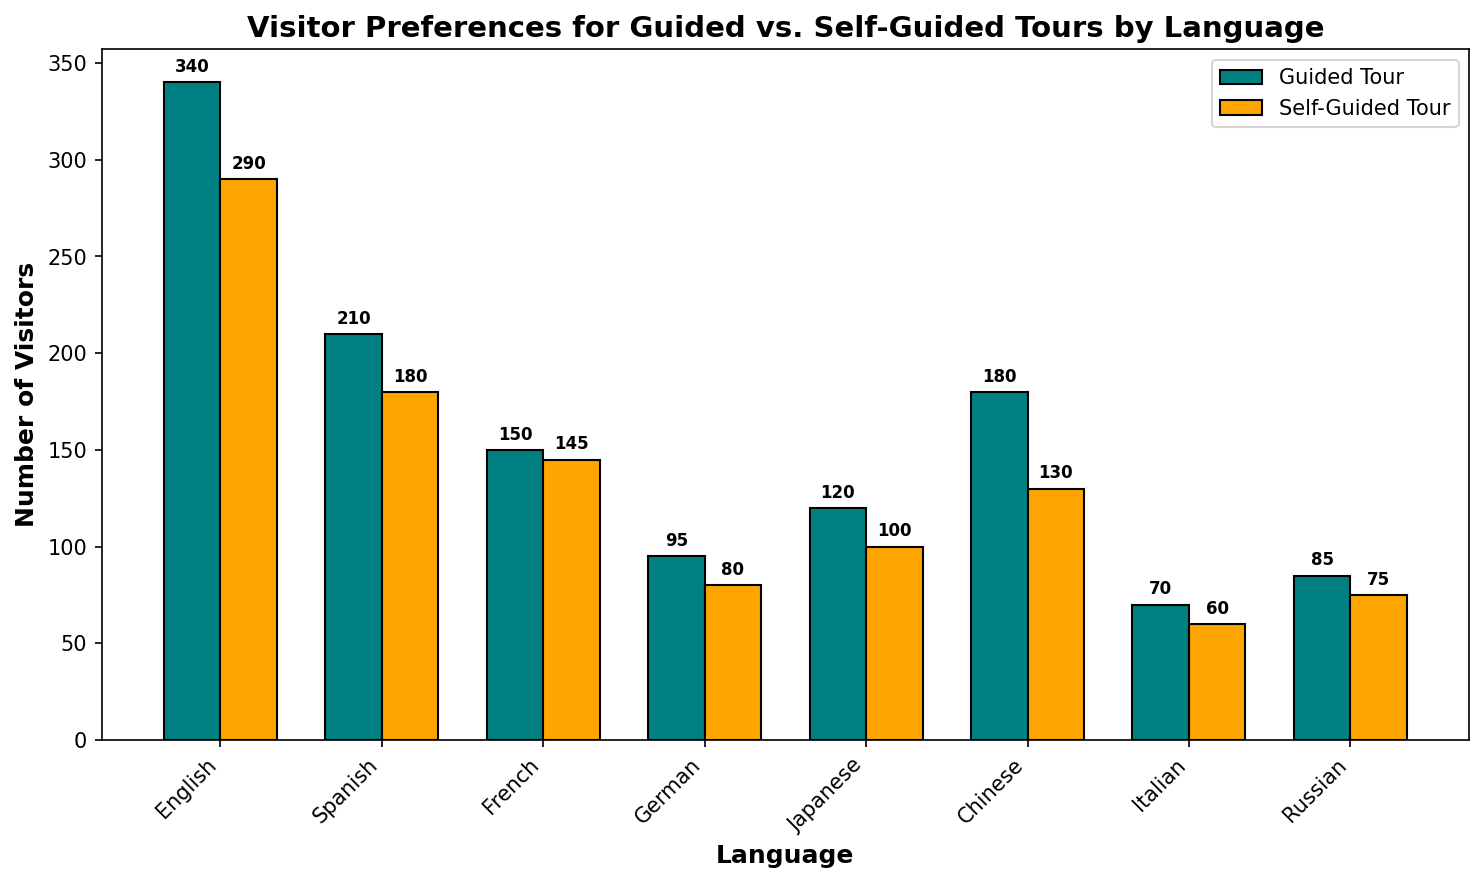Which language has the highest number of visitors for guided tours? To determine the language with the highest number of guided tour visitors, examine the tallest bar among the guided tour bars (teal colored). The English bar is the tallest.
Answer: English Which language has the smallest difference in visitor numbers between guided and self-guided tours? Calculate the difference between guided and self-guided visitors for each language and find the smallest difference. The differences are: English (50), Spanish (30), French (5), German (15), Japanese (20), Chinese (50), Italian (10), and Russian (10). The smallest difference is for French (5).
Answer: French What is the total number of visitors for the German language tours? Add the number of visitors for both guided and self-guided tours for German: 95 (guided) + 80 (self-guided) = 175.
Answer: 175 Compare the visitor numbers for self-guided and guided tours for the Japanese language. Which one has more visitors and by how much? Check the height of the bars for Japanese language. Guided Tour has 120 visitors, and Self-Guided Tour has 100 visitors. Difference is 120 - 100 = 20.
Answer: Guided Tours by 20 What is the average number of visitors for guided tours across all languages? Calculate the sum of all guided tour visitors and divide by the number of languages. Sum of guided tours: 340 + 210 + 150 + 95 + 120 + 180 + 70 + 85 = 1250. Number of languages: 8. Average: 1250 / 8 = 156.25
Answer: 156.25 Which two languages have the closest number of visitors for self-guided tours? Calculate the difference in self-guided tour visitors between all pairs of languages and find the pair with the smallest difference. The smallest difference is between French (145) and Spanish (180 - 145 = 35). Other differences are larger.
Answer: French and Spanish How many total visitors are there for all self-guided tours? Sum the number of visitors for all self-guided tours: 290 + 180 + 145 + 80 + 100 + 130 + 60 + 75 = 1060.
Answer: 1060 Which language has more visitors for self-guided tours compared to guided tours? Compare the heights of the self-guided and guided tour bars for each language. If the self-guided bar is taller, that language has more visitors for self-guided tours. Only Russian (75 vs. 85) has this case.
Answer: Russian What is the difference between the number of visitors for Chinese guided tours and English self-guided tours? Subtract the number of visitors for English self-guided tours from Chinese guided tours: 180 (Chinese guided) - 290 (English self-guided) = -110.
Answer: -110 